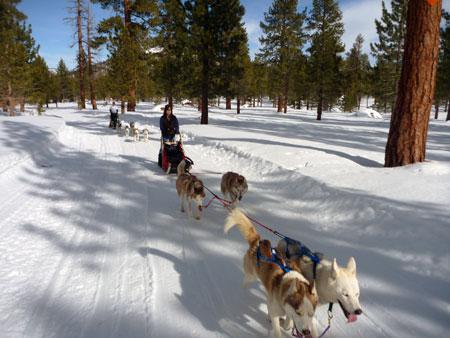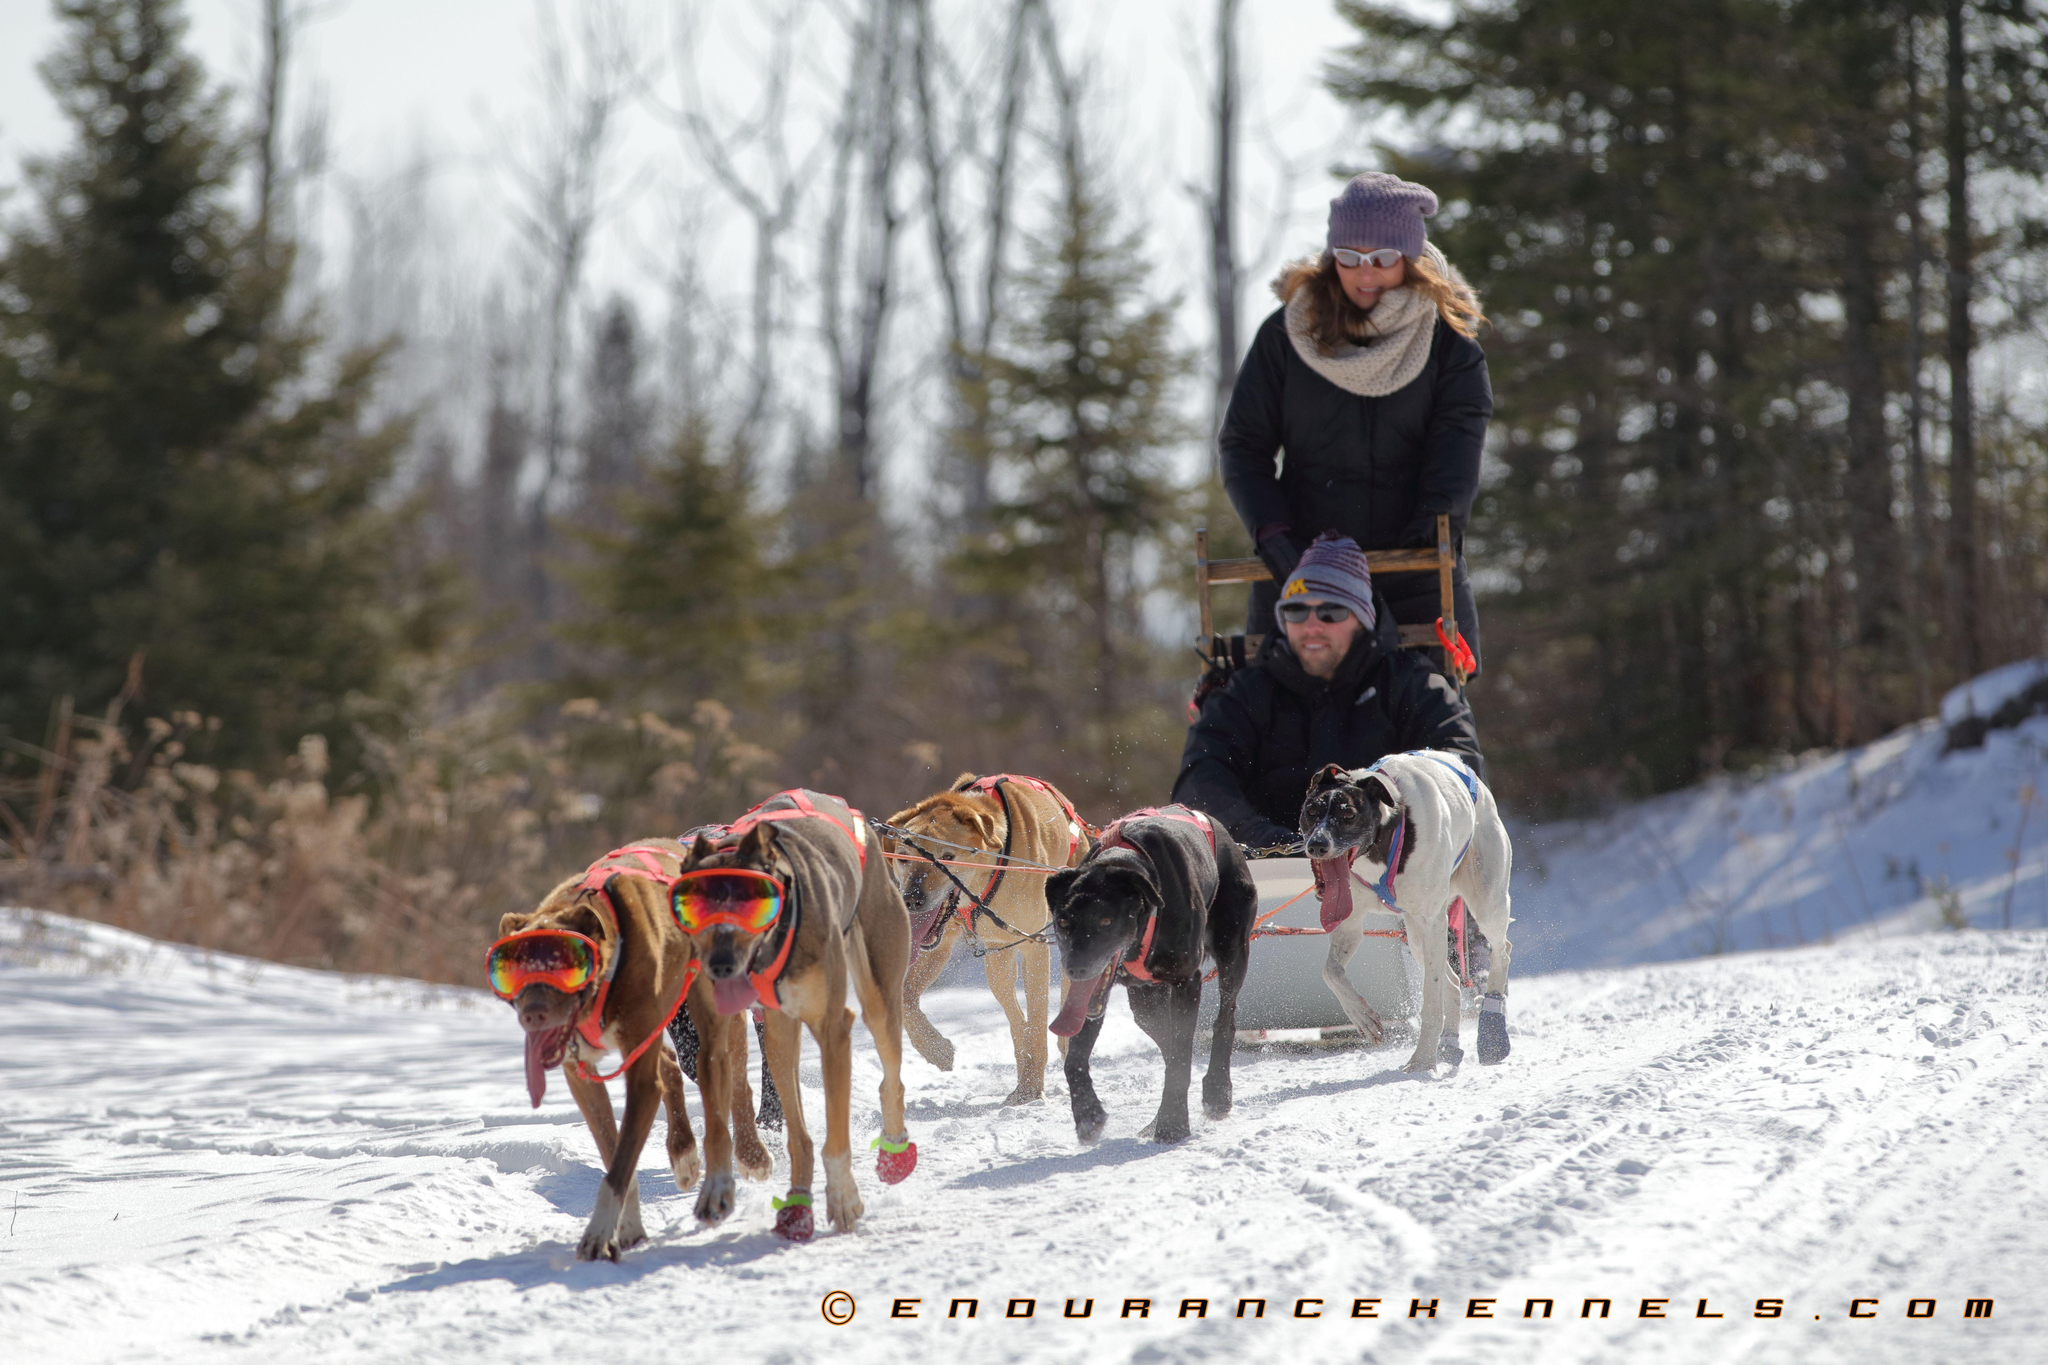The first image is the image on the left, the second image is the image on the right. For the images shown, is this caption "The person in the sled in the image on the left is wearing a white numbered vest." true? Answer yes or no. No. The first image is the image on the left, the second image is the image on the right. Considering the images on both sides, is "One of the sleds is pulled by no more than 3 dogs." valid? Answer yes or no. No. 